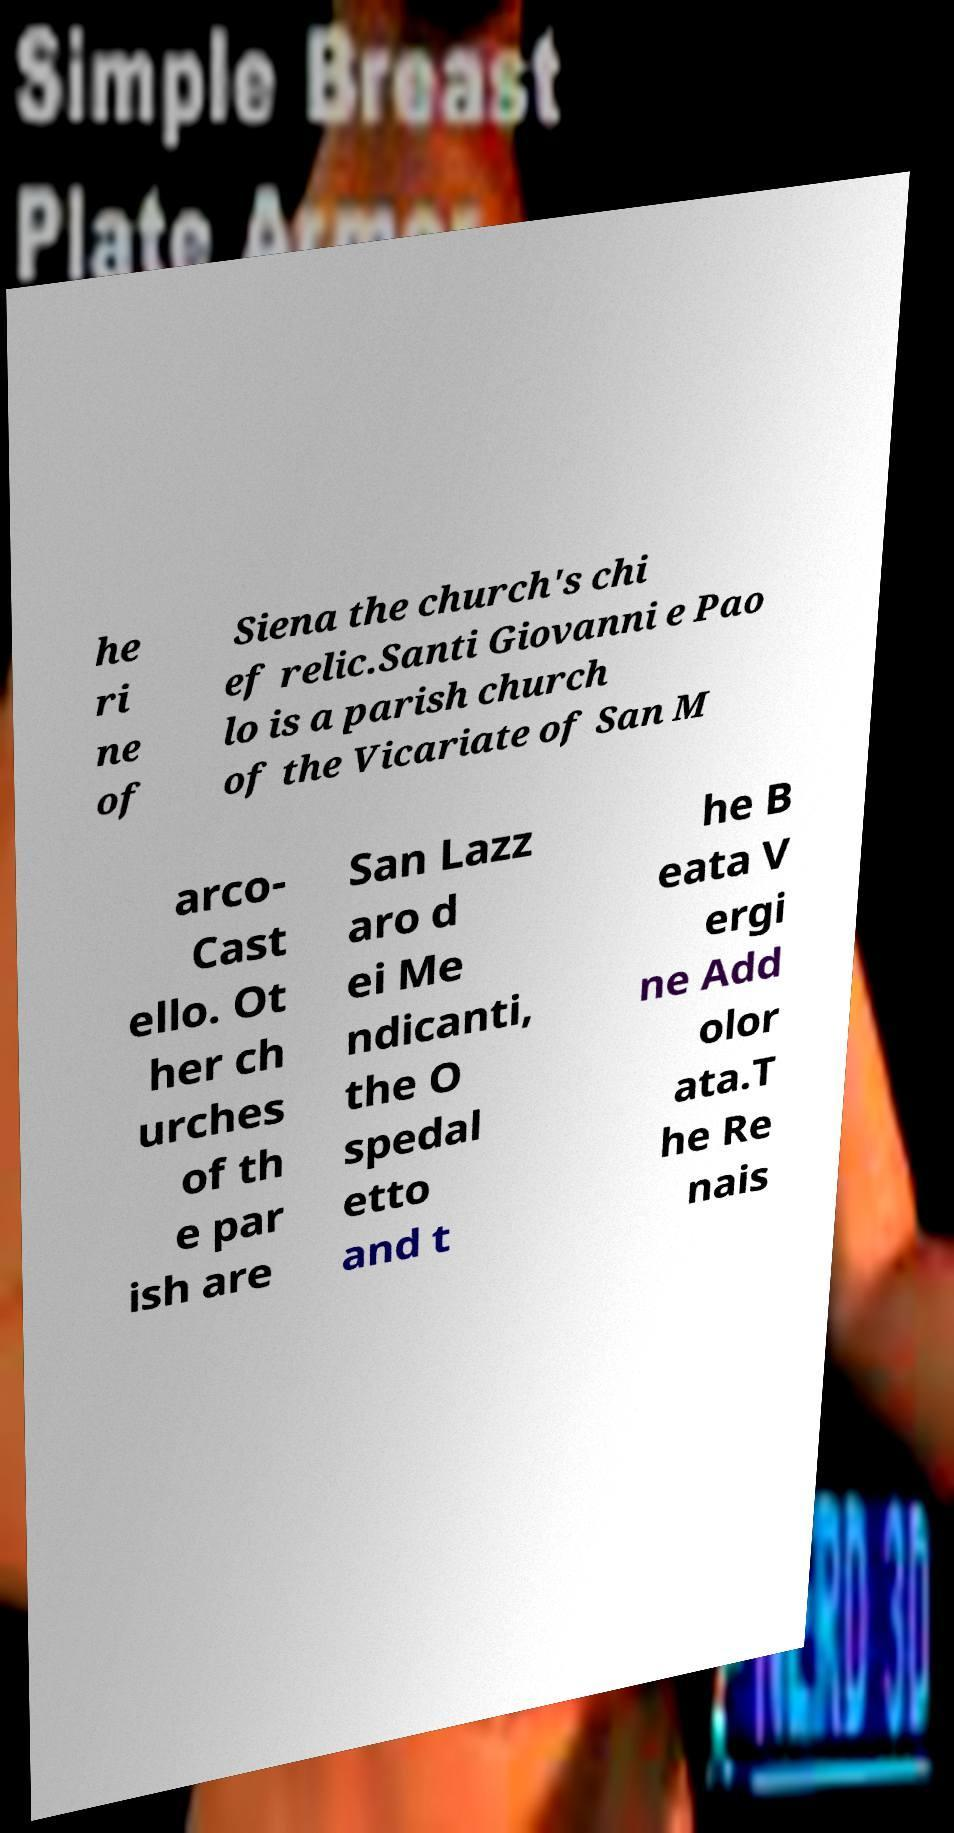For documentation purposes, I need the text within this image transcribed. Could you provide that? he ri ne of Siena the church's chi ef relic.Santi Giovanni e Pao lo is a parish church of the Vicariate of San M arco- Cast ello. Ot her ch urches of th e par ish are San Lazz aro d ei Me ndicanti, the O spedal etto and t he B eata V ergi ne Add olor ata.T he Re nais 